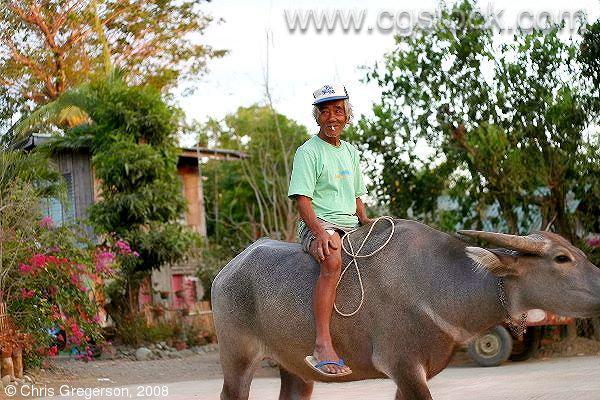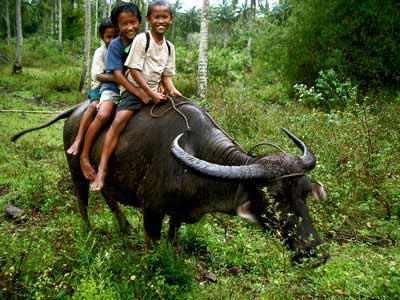The first image is the image on the left, the second image is the image on the right. Given the left and right images, does the statement "At least one water buffalo is standing in water in the left image." hold true? Answer yes or no. No. The first image is the image on the left, the second image is the image on the right. Considering the images on both sides, is "The right image contains at least two people riding on a water buffalo." valid? Answer yes or no. Yes. 